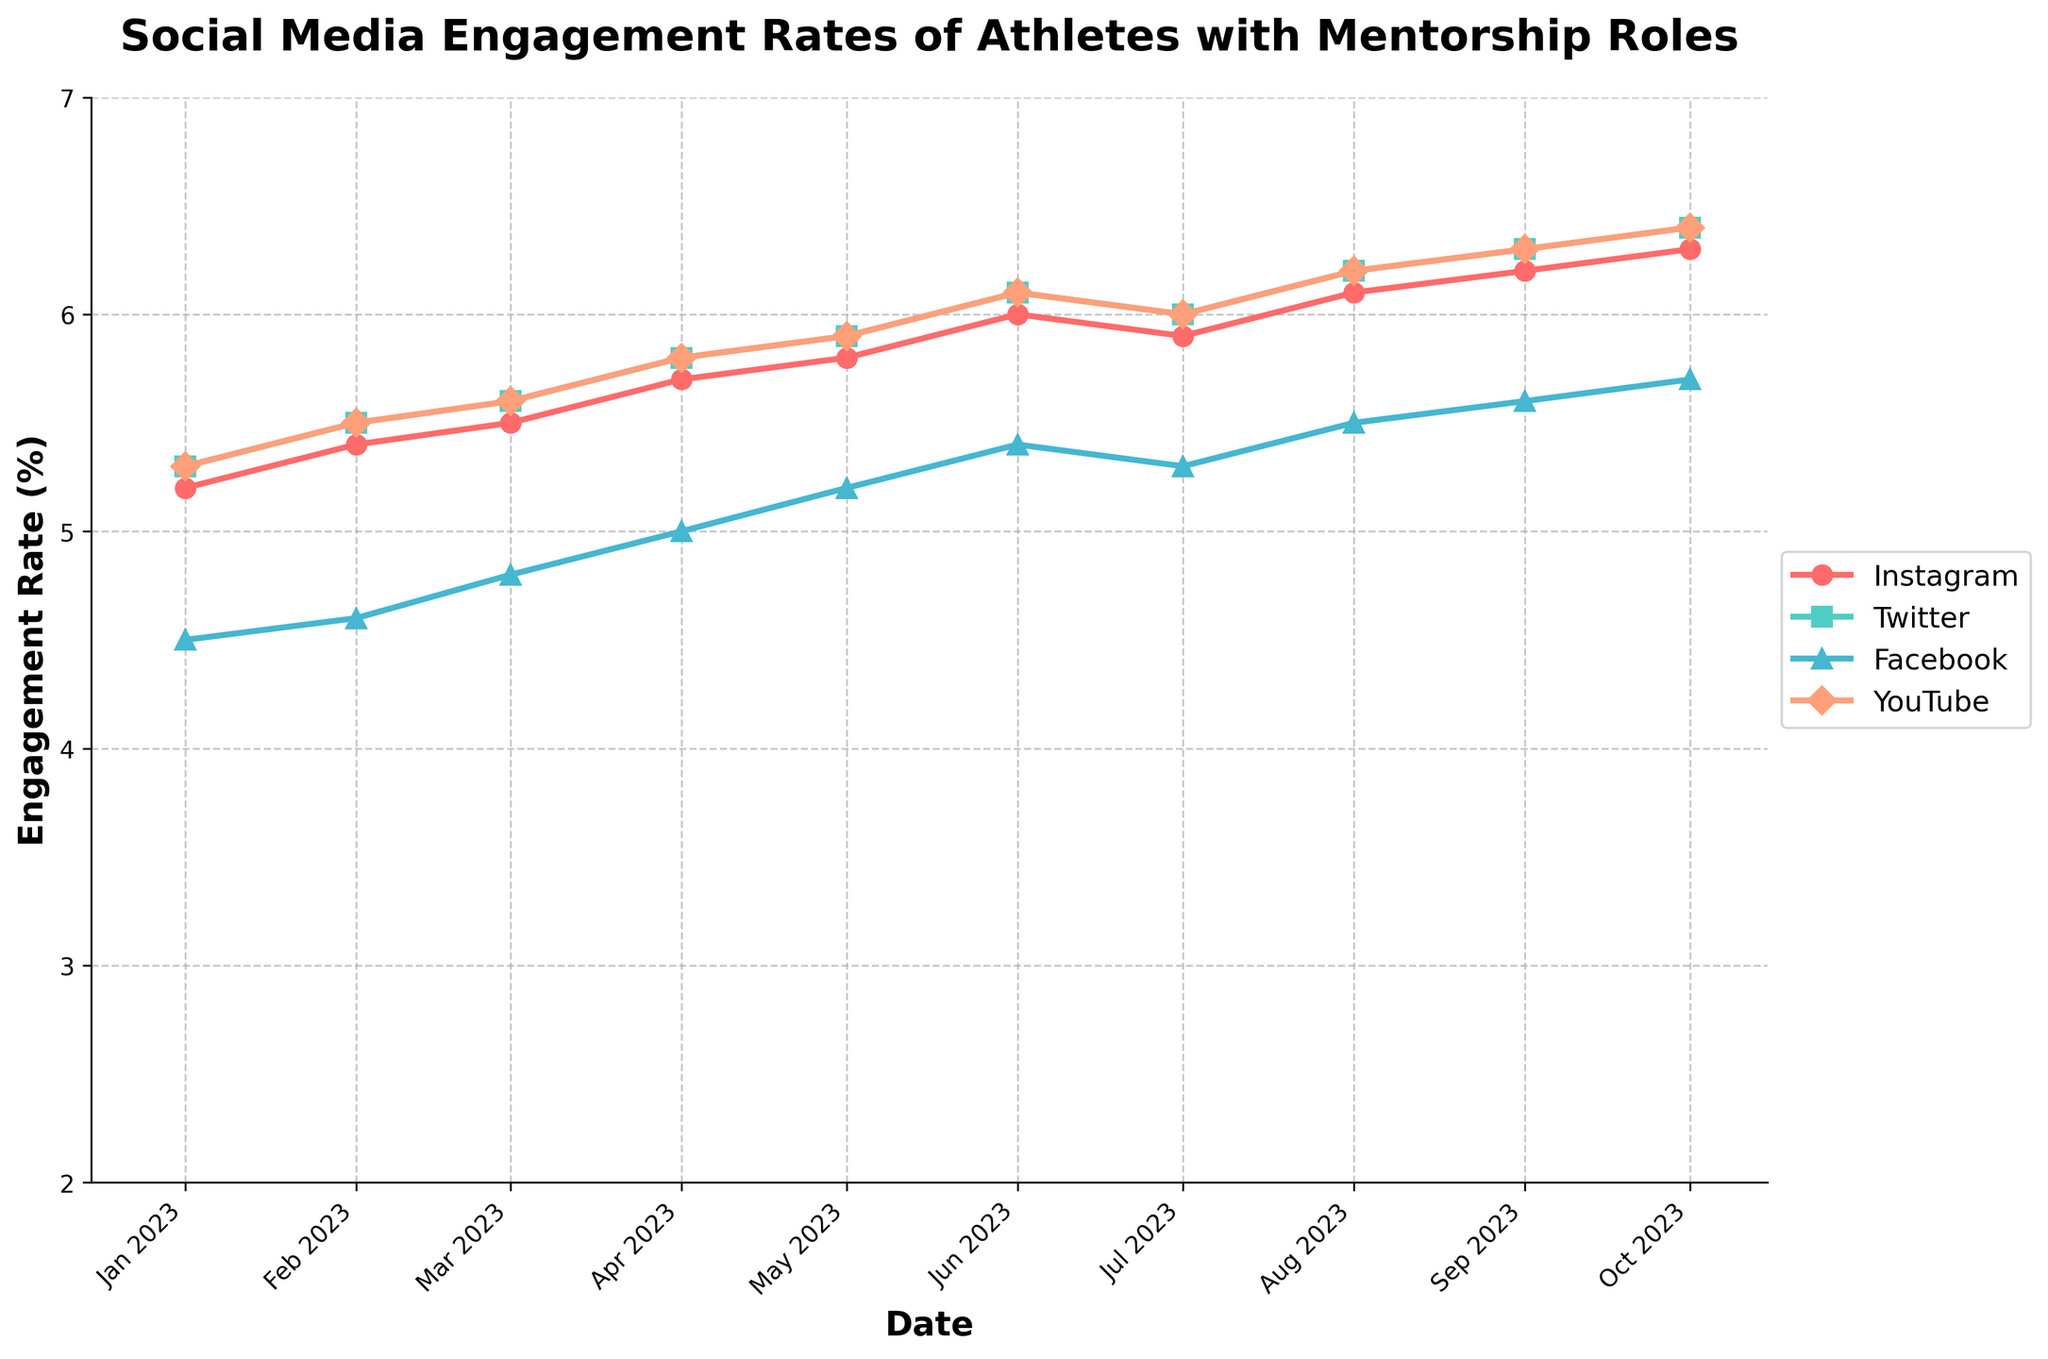What is the title of the figure? The title of the figure is typically located at the top and is the largest, bold text that describes the main topic of the chart. Here, it reads "Social Media Engagement Rates of Athletes with Mentorship Roles".
Answer: Social Media Engagement Rates of Athletes with Mentorship Roles Which platform shows the highest engagement rate in October 2023? To find this, look at the values plotted for each platform corresponding to October 2023. The scale on the left indicates the engagement rates. Instagram shows the highest rate at 6.3%.
Answer: Instagram What is the overall trend of engagement rates for YouTube over the period? Look for the plotted line corresponding to YouTube (colored legend helps identify). From January to October 2023, the engagement rate rises steadily from 5.3% to 6.4%.
Answer: It generally increases Which platform experienced the least variation in engagement rates over the period? To answer this, observe the steepness and fluctuations of each plotted line. Facebook's line (orange) appears to be the least fluctuating and varies only slightly compared to others.
Answer: Facebook What is the average engagement rate for Twitter over the entire period? Calculate the average by summing the engagement rates for Twitter for each month and dividing by the number of months: (5.3 + 5.5 + 5.6 + 5.8 + 5.9 + 6.1 + 6.0 + 6.2 + 6.3 + 6.4) / 10 = 59.1 / 10.
Answer: 5.91% How much did the engagement rate for Instagram increase from January to October 2023? Look at the data points for Instagram in January (5.2%) and October (6.3%). Subtract the January value from the October value: 6.3 - 5.2 = 1.1.
Answer: 1.1% In which month did Facebook surpass 5.5% engagement rate? Identify the Facebook plot line and locate the point where it crosses over the 5.5% mark. It happens in August, 2023.
Answer: August 2023 Compare the engagement rates of YouTube and Facebook in July 2023. Which one is higher? Refer to the data points for July 2023 for both YouTube and Facebook. YouTube's rate is 6.0% while Facebook’s is 5.3%. Therefore, YouTube’s rate is higher.
Answer: YouTube Which platform shows the steepest increase in engagement rate from the beginning to the end of the observed period? The platform with the steepest increase will have the line with the most upward trend. Instagram shows the highest increase from 5.2% to 6.3%.
Answer: Instagram By how much does the engagement rate of YouTube differ from Instagram in September 2023? Find YouTube’s and Instagram’s engagement rates for September 2023 which are 6.3% and 6.2% respectively. Subtract YouTube’s rate from Instagram’s rate: 6.3 - 6.2 = 0.1.
Answer: 0.1% 